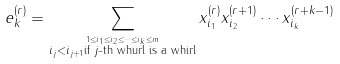Convert formula to latex. <formula><loc_0><loc_0><loc_500><loc_500>e _ { k } ^ { ( r ) } & = \sum _ { \stackrel { 1 \leq i _ { 1 } \leq i _ { 2 } \leq \cdots \leq i _ { k } \leq m } { i _ { j } < i _ { j + 1 } \text {if $j$-th whurl is a whirl} } } x _ { i _ { 1 } } ^ { ( r ) } x _ { i _ { 2 } } ^ { ( r + 1 ) } \cdots x _ { i _ { k } } ^ { ( r + k - 1 ) }</formula> 